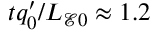<formula> <loc_0><loc_0><loc_500><loc_500>t q _ { 0 } ^ { \prime } / L _ { \mathcal { E } 0 } \approx 1 . 2</formula> 